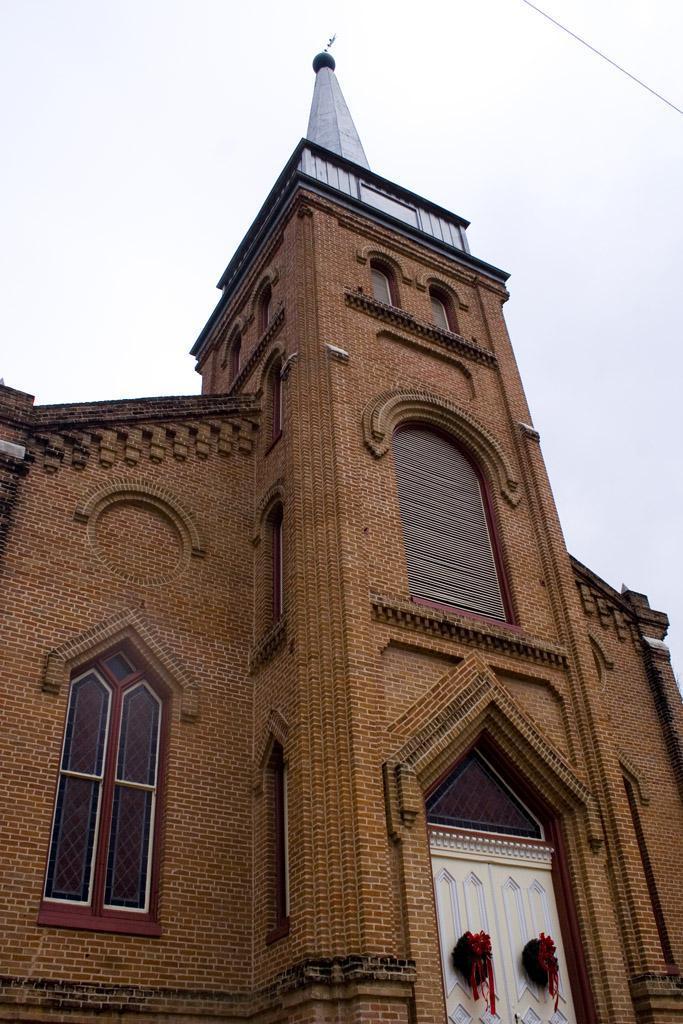How would you summarize this image in a sentence or two? In this image there is the sky, there is a wire truncated towards the left of the image, there is a church truncated, there are windows, there are objects on the door. 